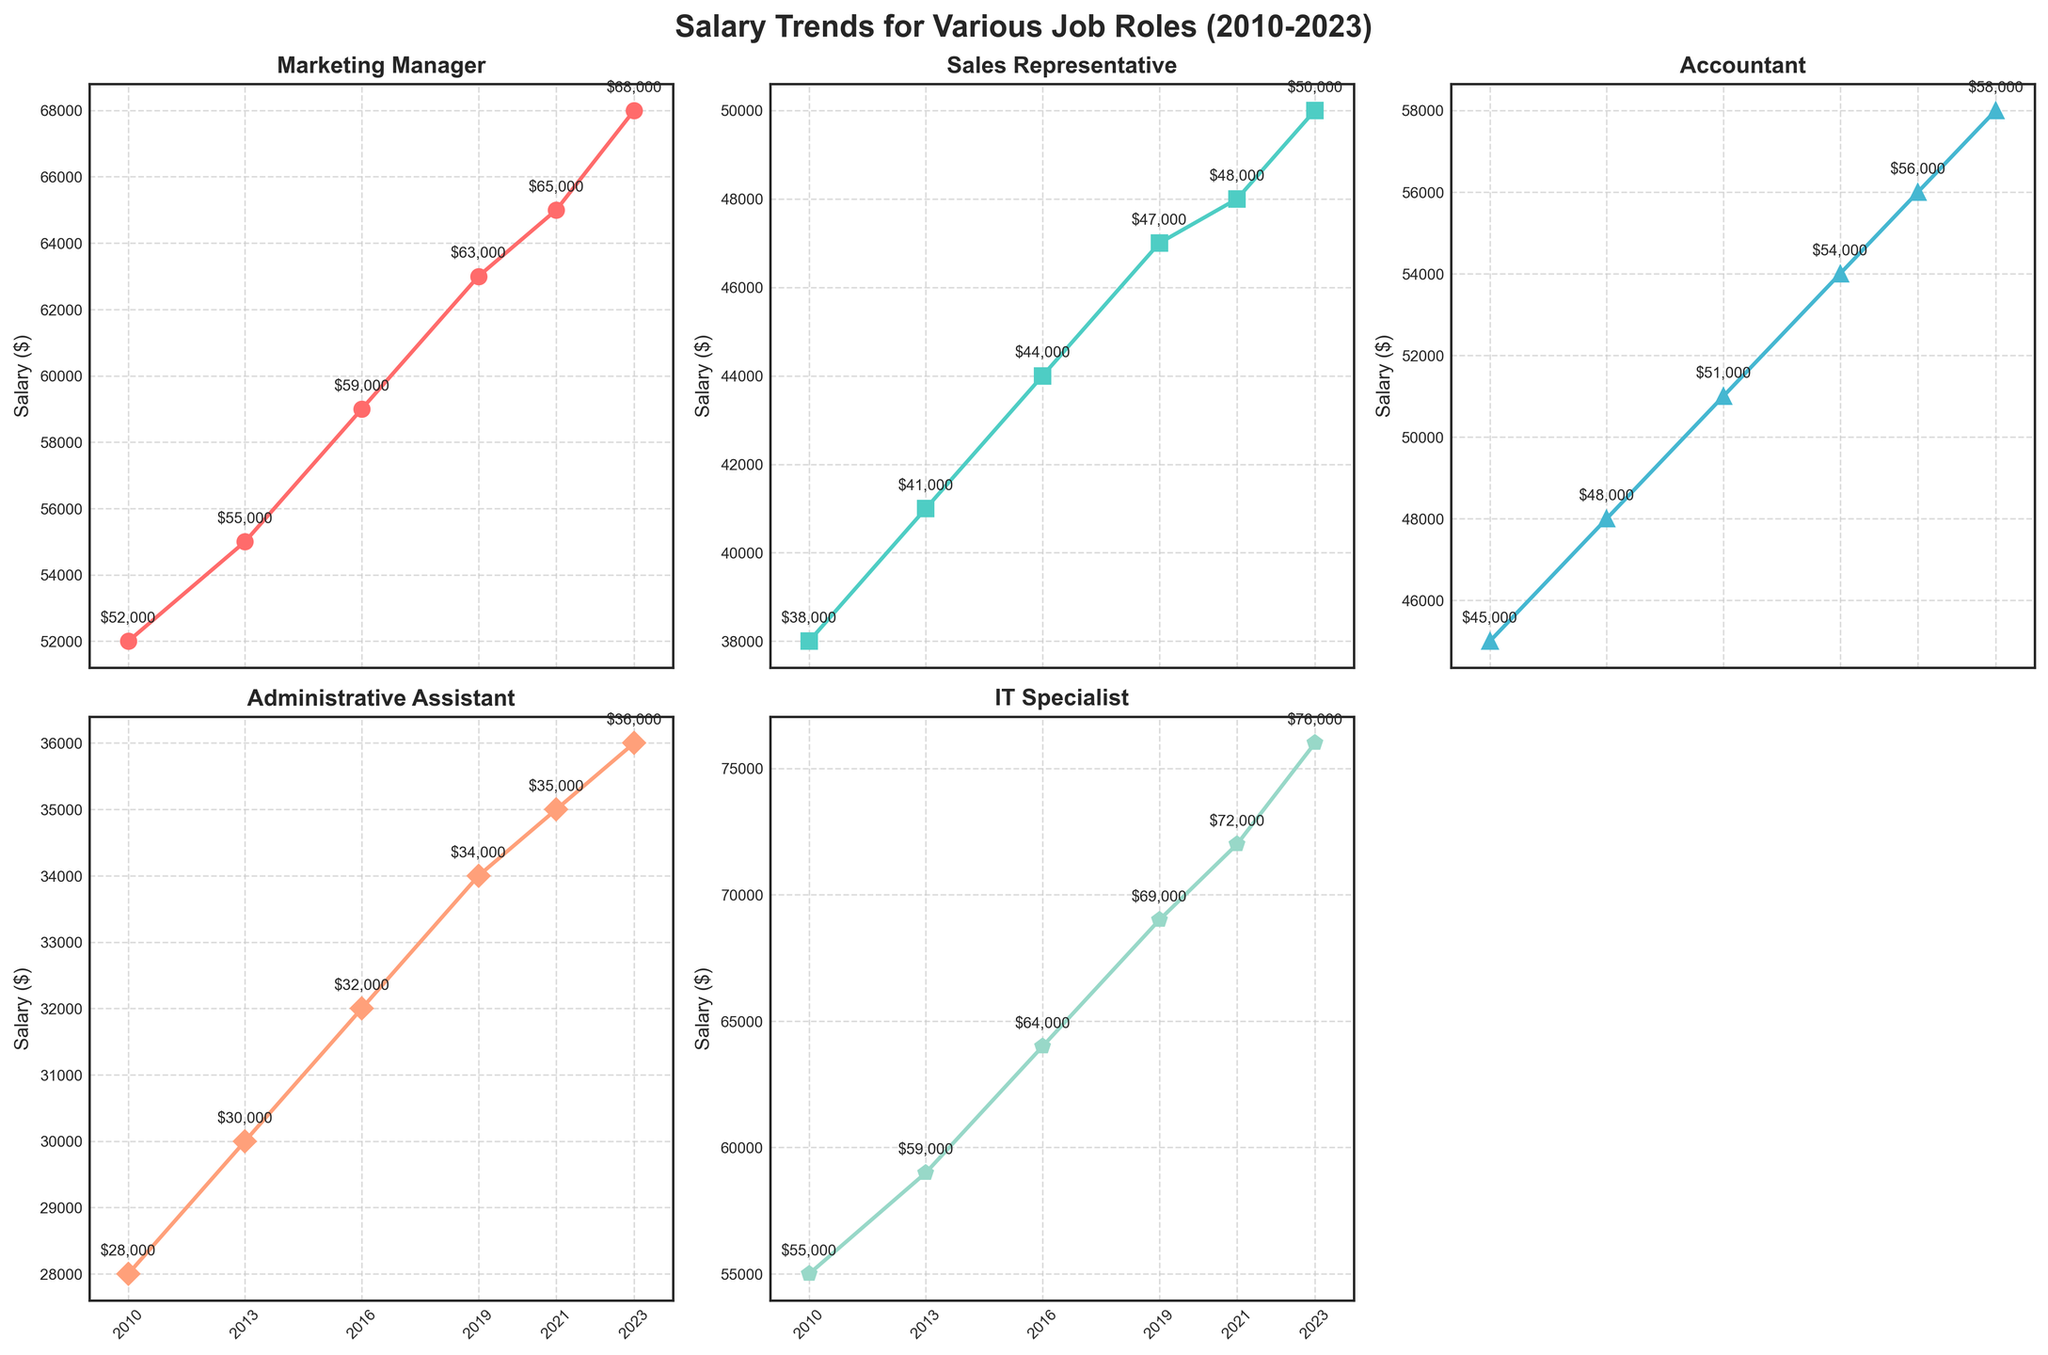What is the title of the figure? The title is displayed at the top center of the figure, indicating the overall topic of the visual data.
Answer: Salary Trends for Various Job Roles (2010-2023) What is the average salary of an Accountant in the years shown? To find the average salary of an Accountant from 2010 to 2023, sum the salaries for each year and divide by the number of years. ($45,000 + $48,000 + $51,000 + $54,000 + $56,000 + $58,000) / 6 = $52,000
Answer: $52,000 Which job role had the highest salary in 2023? Look at the salaries for each job role in 2023 and identify the highest value. IT Specialist had a salary of $76,000 in 2023, the highest among all roles.
Answer: IT Specialist How did the salary trend for Sales Representatives change from 2010 to 2023? Analyze the trendline for Sales Representatives and observe the changes over the years. It increased from $38,000 in 2010 to $50,000 in 2023.
Answer: Increasing trend Which job roles have had a continuous increase in salaries from 2010 to 2023? Check the trendlines for each job role. The lines for Marketing Manager, Sales Representative, Accountant, Administrative Assistant, and IT Specialist all show upward trends from 2010 to 2023.
Answer: Marketing Manager, Sales Representative, Accountant, Administrative Assistant, IT Specialist What is the difference in salary between an IT Specialist and an Administrative Assistant in 2023? Subtract the salary of an Administrative Assistant from that of an IT Specialist in 2023. $76,000 (IT Specialist) - $36,000 (Administrative Assistant) = $40,000
Answer: $40,000 Which two job roles had the closest salary values in 2021? Compare the salary values for each job role in 2021 and identify the closest pair. The closest salaries are for Accountant ($56,000) and Sales Representative ($48,000) with a difference of $8,000.
Answer: Accountant and Sales Representative In which year did the Marketing Manager's salary first reach or exceed $60,000? Identify the year in the time series for Marketing Manager that shows a salary equal to or greater than $60,000. The salary first reached $60,000 in 2016.
Answer: 2016 Between 2016 and 2019, which job role had the highest increase in salary? Calculate the salary increase for each job role between 2016 and 2019. The differences are $4,000 (Marketing Manager), $3,000 (Sales Representative), $3,000 (Accountant), $2,000 (Administrative Assistant), and $5,000 (IT Specialist). The highest increase was for IT Specialist.
Answer: IT Specialist 